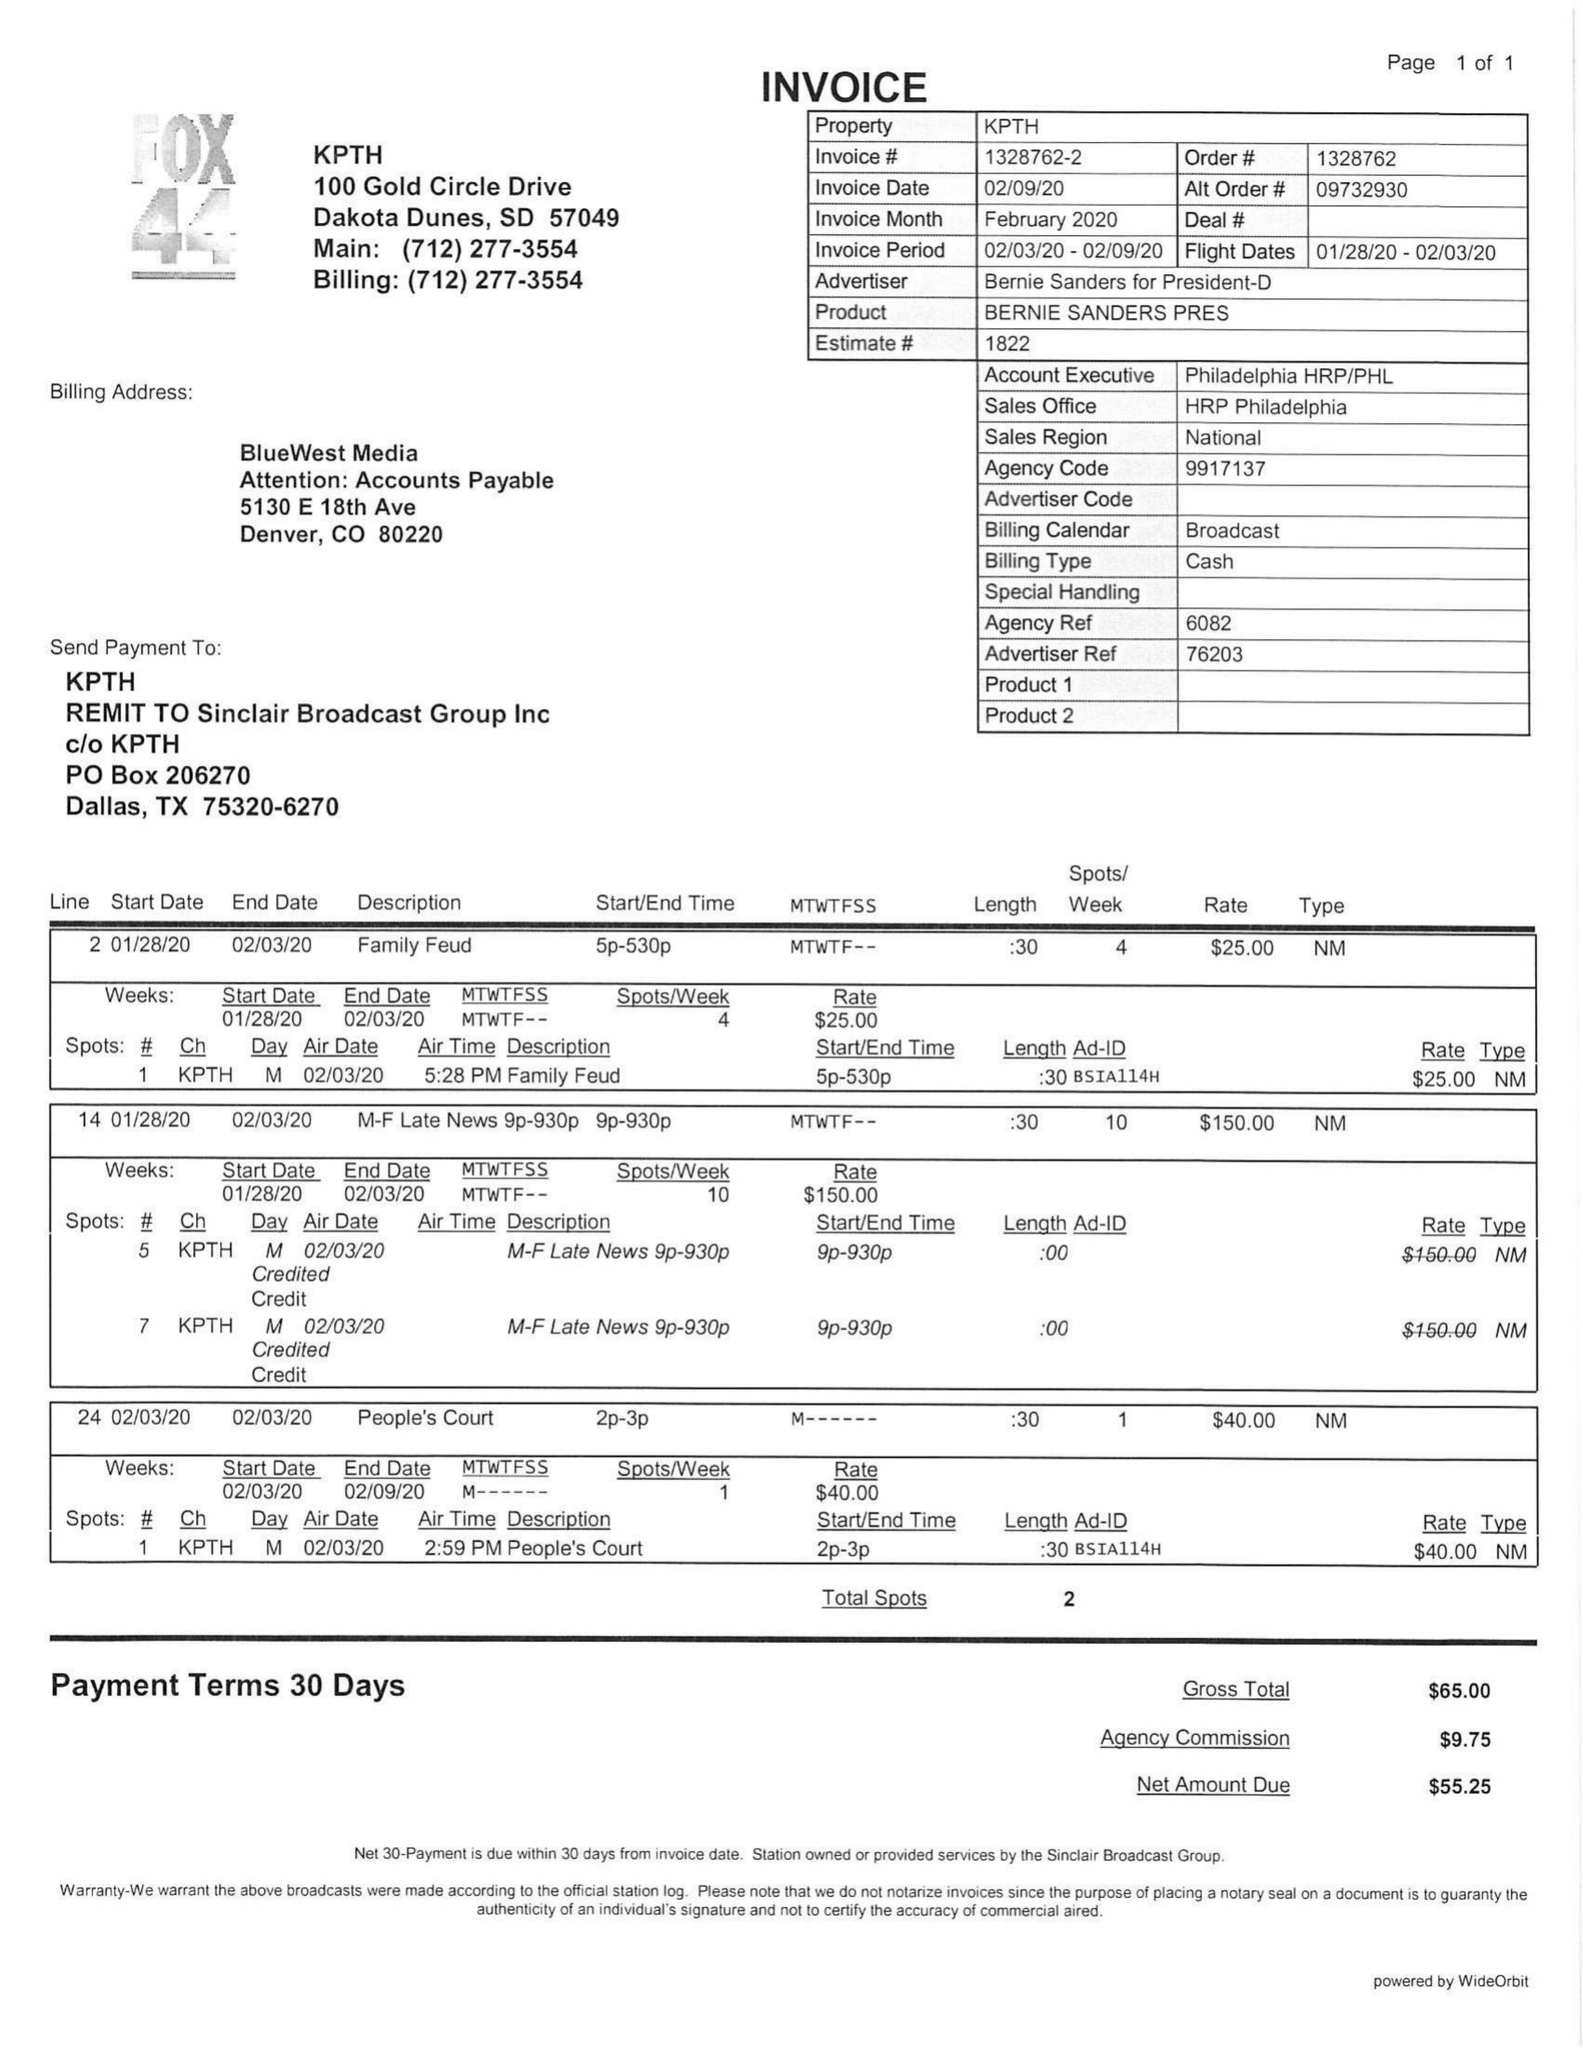What is the value for the flight_from?
Answer the question using a single word or phrase. 01/28/20 